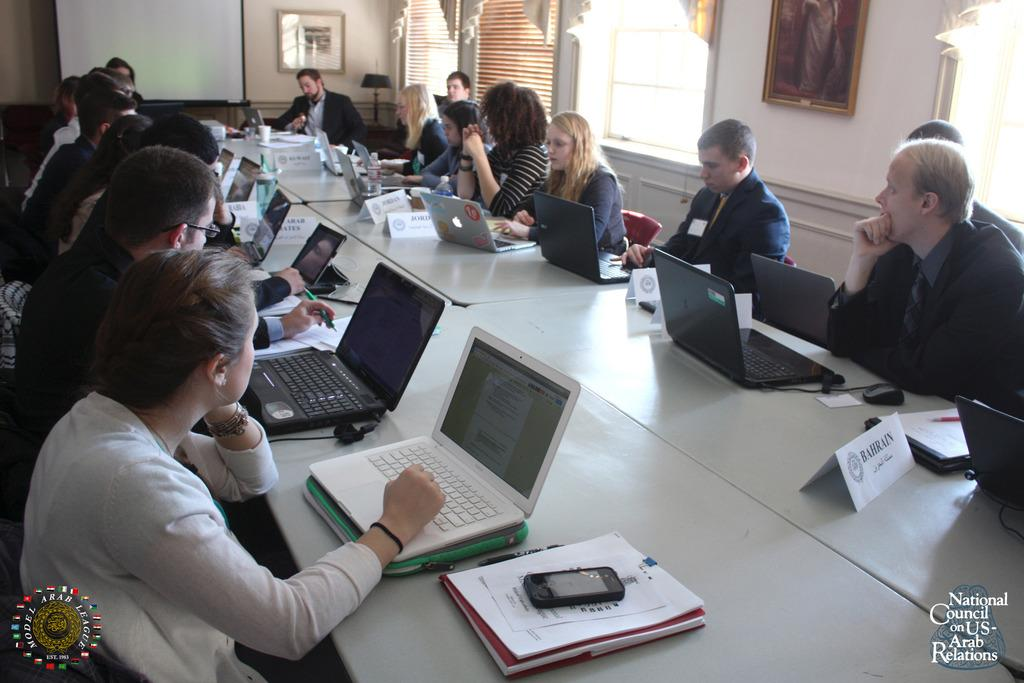<image>
Render a clear and concise summary of the photo. The National Council on US-Arab Relations gathers in a conference room with laptops in front of them. 